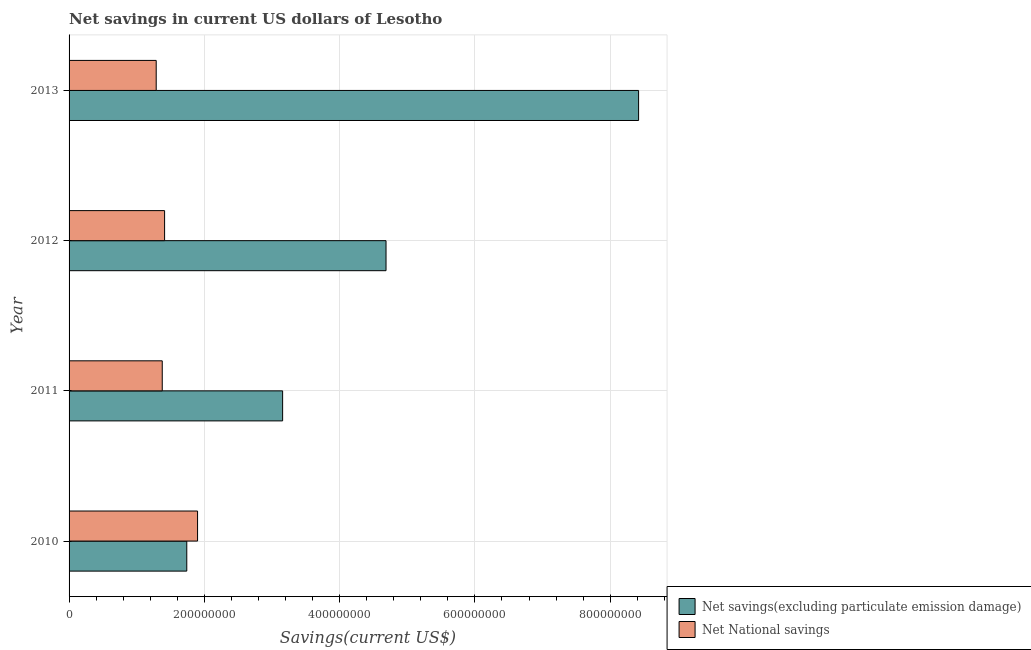How many different coloured bars are there?
Offer a terse response. 2. Are the number of bars per tick equal to the number of legend labels?
Provide a short and direct response. Yes. Are the number of bars on each tick of the Y-axis equal?
Make the answer very short. Yes. How many bars are there on the 1st tick from the top?
Offer a terse response. 2. What is the label of the 3rd group of bars from the top?
Make the answer very short. 2011. What is the net national savings in 2011?
Give a very brief answer. 1.38e+08. Across all years, what is the maximum net savings(excluding particulate emission damage)?
Keep it short and to the point. 8.42e+08. Across all years, what is the minimum net national savings?
Your response must be concise. 1.29e+08. In which year was the net national savings minimum?
Your answer should be very brief. 2013. What is the total net savings(excluding particulate emission damage) in the graph?
Your response must be concise. 1.80e+09. What is the difference between the net national savings in 2011 and that in 2012?
Make the answer very short. -3.47e+06. What is the difference between the net savings(excluding particulate emission damage) in 2012 and the net national savings in 2011?
Your response must be concise. 3.31e+08. What is the average net national savings per year?
Provide a succinct answer. 1.49e+08. In the year 2010, what is the difference between the net national savings and net savings(excluding particulate emission damage)?
Keep it short and to the point. 1.59e+07. In how many years, is the net savings(excluding particulate emission damage) greater than 360000000 US$?
Make the answer very short. 2. What is the ratio of the net national savings in 2010 to that in 2012?
Your response must be concise. 1.34. Is the net savings(excluding particulate emission damage) in 2010 less than that in 2012?
Your answer should be compact. Yes. What is the difference between the highest and the second highest net savings(excluding particulate emission damage)?
Keep it short and to the point. 3.73e+08. What is the difference between the highest and the lowest net national savings?
Keep it short and to the point. 6.11e+07. In how many years, is the net savings(excluding particulate emission damage) greater than the average net savings(excluding particulate emission damage) taken over all years?
Offer a very short reply. 2. What does the 2nd bar from the top in 2012 represents?
Your answer should be very brief. Net savings(excluding particulate emission damage). What does the 2nd bar from the bottom in 2013 represents?
Your response must be concise. Net National savings. How many years are there in the graph?
Provide a short and direct response. 4. What is the difference between two consecutive major ticks on the X-axis?
Offer a very short reply. 2.00e+08. Are the values on the major ticks of X-axis written in scientific E-notation?
Your answer should be compact. No. Where does the legend appear in the graph?
Keep it short and to the point. Bottom right. How are the legend labels stacked?
Offer a very short reply. Vertical. What is the title of the graph?
Your response must be concise. Net savings in current US dollars of Lesotho. Does "Pregnant women" appear as one of the legend labels in the graph?
Make the answer very short. No. What is the label or title of the X-axis?
Offer a very short reply. Savings(current US$). What is the Savings(current US$) in Net savings(excluding particulate emission damage) in 2010?
Provide a succinct answer. 1.74e+08. What is the Savings(current US$) in Net National savings in 2010?
Your answer should be very brief. 1.90e+08. What is the Savings(current US$) of Net savings(excluding particulate emission damage) in 2011?
Give a very brief answer. 3.16e+08. What is the Savings(current US$) in Net National savings in 2011?
Your answer should be very brief. 1.38e+08. What is the Savings(current US$) in Net savings(excluding particulate emission damage) in 2012?
Make the answer very short. 4.69e+08. What is the Savings(current US$) of Net National savings in 2012?
Your response must be concise. 1.41e+08. What is the Savings(current US$) of Net savings(excluding particulate emission damage) in 2013?
Offer a very short reply. 8.42e+08. What is the Savings(current US$) of Net National savings in 2013?
Offer a terse response. 1.29e+08. Across all years, what is the maximum Savings(current US$) of Net savings(excluding particulate emission damage)?
Your response must be concise. 8.42e+08. Across all years, what is the maximum Savings(current US$) in Net National savings?
Offer a very short reply. 1.90e+08. Across all years, what is the minimum Savings(current US$) of Net savings(excluding particulate emission damage)?
Ensure brevity in your answer.  1.74e+08. Across all years, what is the minimum Savings(current US$) of Net National savings?
Your response must be concise. 1.29e+08. What is the total Savings(current US$) of Net savings(excluding particulate emission damage) in the graph?
Offer a terse response. 1.80e+09. What is the total Savings(current US$) of Net National savings in the graph?
Make the answer very short. 5.98e+08. What is the difference between the Savings(current US$) in Net savings(excluding particulate emission damage) in 2010 and that in 2011?
Offer a very short reply. -1.42e+08. What is the difference between the Savings(current US$) of Net National savings in 2010 and that in 2011?
Make the answer very short. 5.22e+07. What is the difference between the Savings(current US$) of Net savings(excluding particulate emission damage) in 2010 and that in 2012?
Your answer should be very brief. -2.95e+08. What is the difference between the Savings(current US$) of Net National savings in 2010 and that in 2012?
Offer a terse response. 4.87e+07. What is the difference between the Savings(current US$) in Net savings(excluding particulate emission damage) in 2010 and that in 2013?
Provide a succinct answer. -6.68e+08. What is the difference between the Savings(current US$) in Net National savings in 2010 and that in 2013?
Offer a terse response. 6.11e+07. What is the difference between the Savings(current US$) in Net savings(excluding particulate emission damage) in 2011 and that in 2012?
Your response must be concise. -1.53e+08. What is the difference between the Savings(current US$) in Net National savings in 2011 and that in 2012?
Provide a succinct answer. -3.47e+06. What is the difference between the Savings(current US$) in Net savings(excluding particulate emission damage) in 2011 and that in 2013?
Ensure brevity in your answer.  -5.26e+08. What is the difference between the Savings(current US$) of Net National savings in 2011 and that in 2013?
Offer a terse response. 8.92e+06. What is the difference between the Savings(current US$) in Net savings(excluding particulate emission damage) in 2012 and that in 2013?
Your answer should be compact. -3.73e+08. What is the difference between the Savings(current US$) in Net National savings in 2012 and that in 2013?
Your response must be concise. 1.24e+07. What is the difference between the Savings(current US$) of Net savings(excluding particulate emission damage) in 2010 and the Savings(current US$) of Net National savings in 2011?
Your answer should be compact. 3.63e+07. What is the difference between the Savings(current US$) of Net savings(excluding particulate emission damage) in 2010 and the Savings(current US$) of Net National savings in 2012?
Provide a short and direct response. 3.28e+07. What is the difference between the Savings(current US$) of Net savings(excluding particulate emission damage) in 2010 and the Savings(current US$) of Net National savings in 2013?
Provide a short and direct response. 4.52e+07. What is the difference between the Savings(current US$) of Net savings(excluding particulate emission damage) in 2011 and the Savings(current US$) of Net National savings in 2012?
Give a very brief answer. 1.74e+08. What is the difference between the Savings(current US$) in Net savings(excluding particulate emission damage) in 2011 and the Savings(current US$) in Net National savings in 2013?
Your response must be concise. 1.87e+08. What is the difference between the Savings(current US$) of Net savings(excluding particulate emission damage) in 2012 and the Savings(current US$) of Net National savings in 2013?
Your response must be concise. 3.40e+08. What is the average Savings(current US$) in Net savings(excluding particulate emission damage) per year?
Keep it short and to the point. 4.50e+08. What is the average Savings(current US$) of Net National savings per year?
Provide a succinct answer. 1.49e+08. In the year 2010, what is the difference between the Savings(current US$) of Net savings(excluding particulate emission damage) and Savings(current US$) of Net National savings?
Provide a succinct answer. -1.59e+07. In the year 2011, what is the difference between the Savings(current US$) in Net savings(excluding particulate emission damage) and Savings(current US$) in Net National savings?
Make the answer very short. 1.78e+08. In the year 2012, what is the difference between the Savings(current US$) in Net savings(excluding particulate emission damage) and Savings(current US$) in Net National savings?
Ensure brevity in your answer.  3.27e+08. In the year 2013, what is the difference between the Savings(current US$) in Net savings(excluding particulate emission damage) and Savings(current US$) in Net National savings?
Keep it short and to the point. 7.13e+08. What is the ratio of the Savings(current US$) of Net savings(excluding particulate emission damage) in 2010 to that in 2011?
Your response must be concise. 0.55. What is the ratio of the Savings(current US$) of Net National savings in 2010 to that in 2011?
Keep it short and to the point. 1.38. What is the ratio of the Savings(current US$) in Net savings(excluding particulate emission damage) in 2010 to that in 2012?
Your answer should be very brief. 0.37. What is the ratio of the Savings(current US$) in Net National savings in 2010 to that in 2012?
Offer a terse response. 1.35. What is the ratio of the Savings(current US$) in Net savings(excluding particulate emission damage) in 2010 to that in 2013?
Your answer should be compact. 0.21. What is the ratio of the Savings(current US$) of Net National savings in 2010 to that in 2013?
Keep it short and to the point. 1.47. What is the ratio of the Savings(current US$) in Net savings(excluding particulate emission damage) in 2011 to that in 2012?
Keep it short and to the point. 0.67. What is the ratio of the Savings(current US$) in Net National savings in 2011 to that in 2012?
Make the answer very short. 0.98. What is the ratio of the Savings(current US$) in Net National savings in 2011 to that in 2013?
Provide a short and direct response. 1.07. What is the ratio of the Savings(current US$) in Net savings(excluding particulate emission damage) in 2012 to that in 2013?
Make the answer very short. 0.56. What is the ratio of the Savings(current US$) in Net National savings in 2012 to that in 2013?
Your answer should be very brief. 1.1. What is the difference between the highest and the second highest Savings(current US$) in Net savings(excluding particulate emission damage)?
Your answer should be very brief. 3.73e+08. What is the difference between the highest and the second highest Savings(current US$) of Net National savings?
Provide a succinct answer. 4.87e+07. What is the difference between the highest and the lowest Savings(current US$) in Net savings(excluding particulate emission damage)?
Your answer should be very brief. 6.68e+08. What is the difference between the highest and the lowest Savings(current US$) in Net National savings?
Your answer should be very brief. 6.11e+07. 